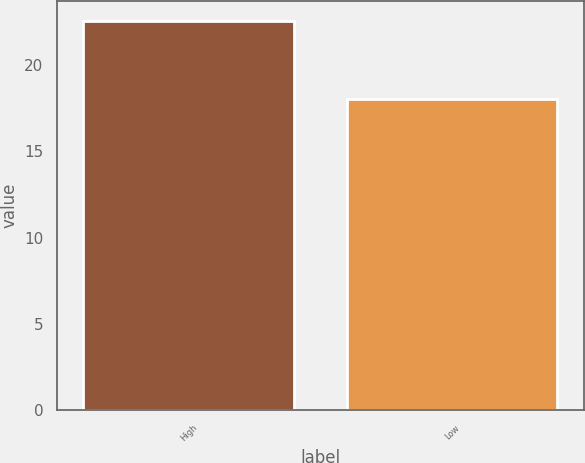Convert chart to OTSL. <chart><loc_0><loc_0><loc_500><loc_500><bar_chart><fcel>High<fcel>Low<nl><fcel>22.59<fcel>18.01<nl></chart> 